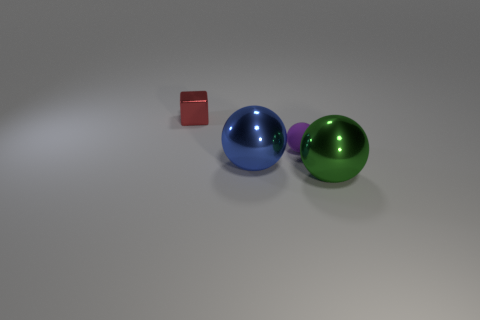What does the arrangement of these objects suggest about their relative sizes? The arrangement of the objects implies that the blue and green spheres are larger than the red cube, as they both visually appear to take up more space within the frame of the image. Is there any indication of the objects' potential weight based on this image? Based on the image alone, we can't accurately determine the exact weight of the objects, but the shadows suggest they are resting solidly on the surface, which might imply a certain heft, consistent with objects of their apparent sizes made of dense materials. 